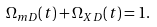<formula> <loc_0><loc_0><loc_500><loc_500>\Omega _ { m D } ( t ) + \Omega _ { X D } ( t ) = 1 .</formula> 